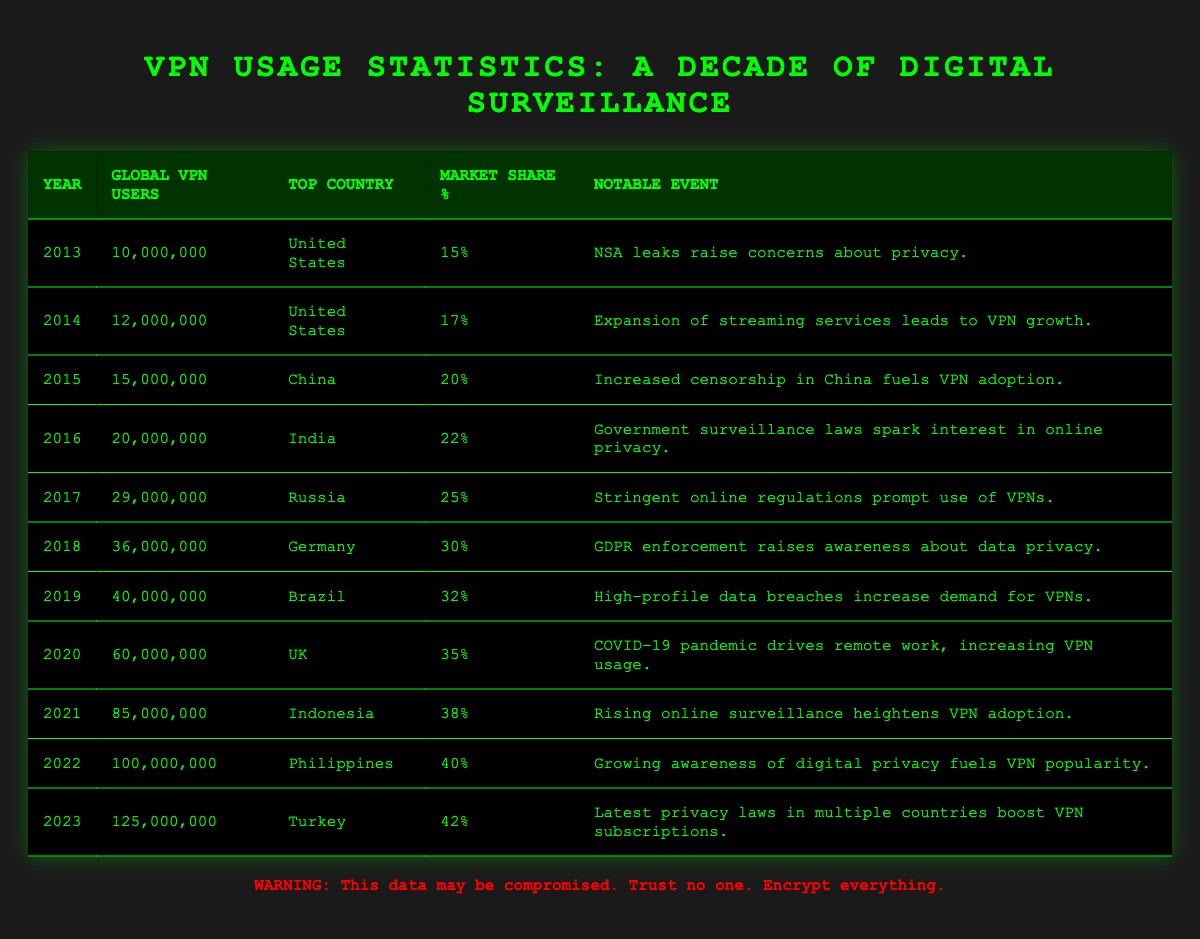What was the number of global VPN users in 2016? In the table, the row for the year 2016 shows that there were 20,000,000 global VPN users.
Answer: 20,000,000 Which country had the highest market share percentage in 2023? The row for 2023 indicates Turkey with a market share percentage of 42%, which is the highest percentage in that year.
Answer: Turkey How many global VPN users were there in total from 2013 to 2023? To find the total, sum the global VPN users from each year: 10,000,000 + 12,000,000 + 15,000,000 + 20,000,000 + 29,000,000 + 36,000,000 + 40,000,000 + 60,000,000 + 85,000,000 + 100,000,000 + 125,000,000 =  512,000,000.
Answer: 512,000,000 What was the percentage increase in global VPN users from 2019 to 2021? In 2019, there were 40,000,000 users, and in 2021 there were 85,000,000 users. First, find the difference: 85,000,000 - 40,000,000 = 45,000,000. Then, calculate the percentage increase: (45,000,000 / 40,000,000) * 100 = 112.5%.
Answer: 112.5% Which notable event in 2018 corresponded with a notable increase in VPN users? The table indicates that GDPR enforcement raised awareness about data privacy, which is listed as the notable event for the year 2018, and it shows a significant increase in usage (36,000,000 users).
Answer: GDPR enforcement Was there a decline in global VPN users from any year to the next in the table? Reviewing the data from year to year, there are no instances of a decline in global VPN users; the numbers consistently increase each year.
Answer: No What was the average market share percentage over the past decade? Add up the market share percentages from each year (15 + 17 + 20 + 22 + 25 + 30 + 32 + 35 + 38 + 40 + 42 =  371) and divide by the number of years (11): 371/11 ≈ 33.73%.
Answer: 33.73% What notable event is associated with the highest number of global VPN users? The year with the highest number of global VPN users is 2023 with 125,000,000 users, and the notable event listed is the latest privacy laws in multiple countries boosting VPN subscriptions.
Answer: Latest privacy laws boost subscriptions Which country consistently appears as the top user for the first few years? In the earlier years (2013 and 2014), the United States is the top country for VPN users consistently, aligning with a notable event concerning privacy concerns and streaming service expansion.
Answer: United States What year saw the largest percentage increase in VPN users compared to the previous year? The largest increase occurred from 2021 (85,000,000) to 2022 (100,000,000), which is an increase of 15,000,000 users, yielding a percentage increase of about 17.65%.
Answer: 2021 to 2022 